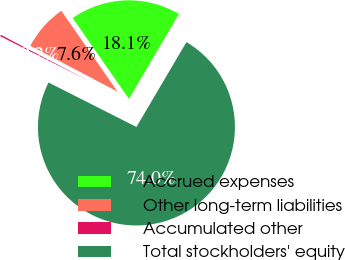Convert chart to OTSL. <chart><loc_0><loc_0><loc_500><loc_500><pie_chart><fcel>Accrued expenses<fcel>Other long-term liabilities<fcel>Accumulated other<fcel>Total stockholders' equity<nl><fcel>18.15%<fcel>7.62%<fcel>0.25%<fcel>73.98%<nl></chart> 